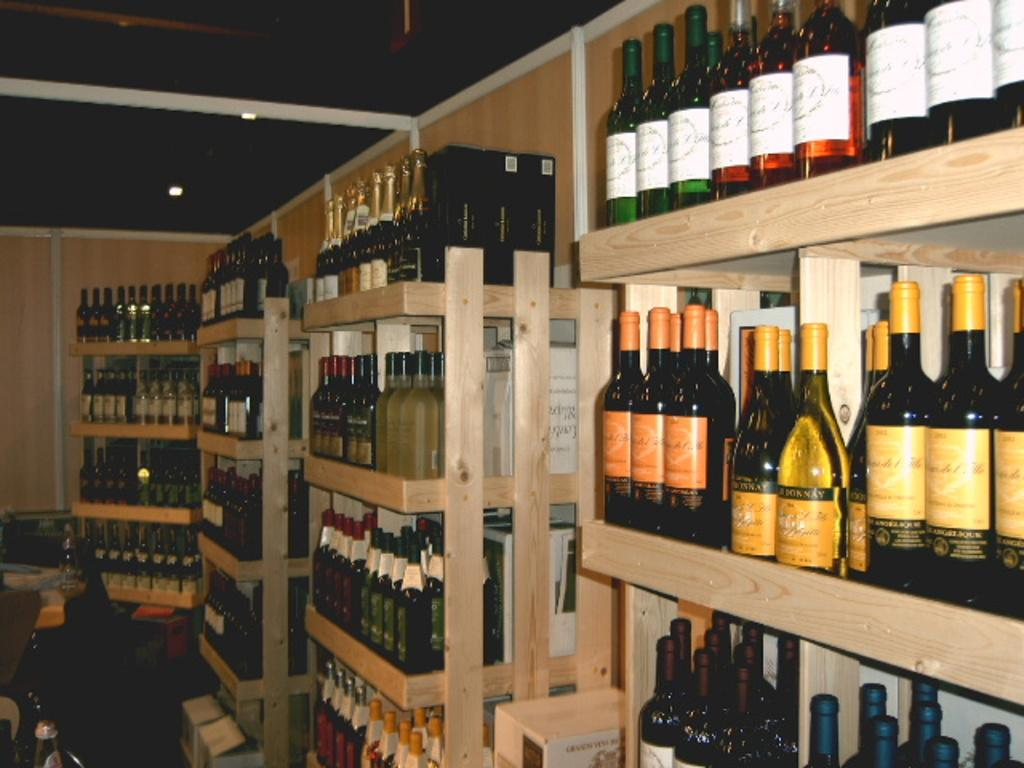What type of containers are visible in the image? There are alcohol bottles in the image. How are the alcohol bottles arranged? The alcohol bottles are arranged on wooden racks. What can be seen behind the bottles? There is a wall visible in the image. What provides illumination in the image? Ceiling lights are attached to the ceiling in the image. Can you see any cats playing near the river in the image? There is no river or cats present in the image; it features alcohol bottles arranged on wooden racks with a wall and ceiling lights. 